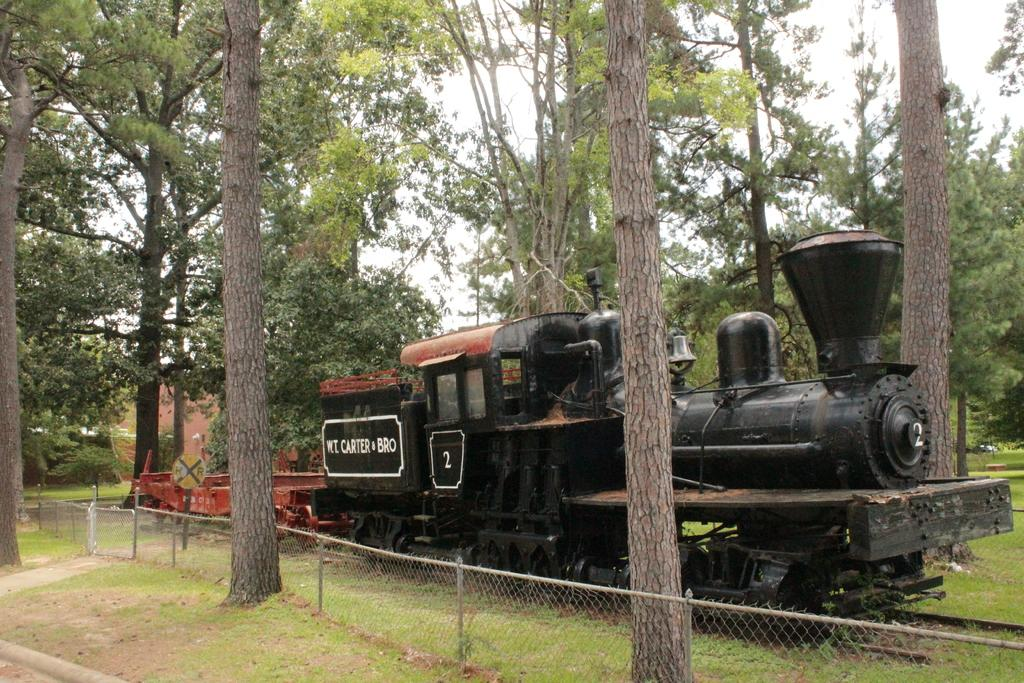What type of vehicle is in the image? There is a steam engine in the image. What type of vegetation is present in the image? There is grass in the image. What type of barrier is in the image? There is a fence in the image. What type of natural feature is in the image? There are trees in the image. What is the color of the sky in the image? The sky is white in the image. What caption is written on the steam engine in the image? There is no caption visible on the steam engine in the image. Can you see the parent of the steam engine in the image? There is no parent figure present in the image, as it features a steam engine and other inanimate objects. 